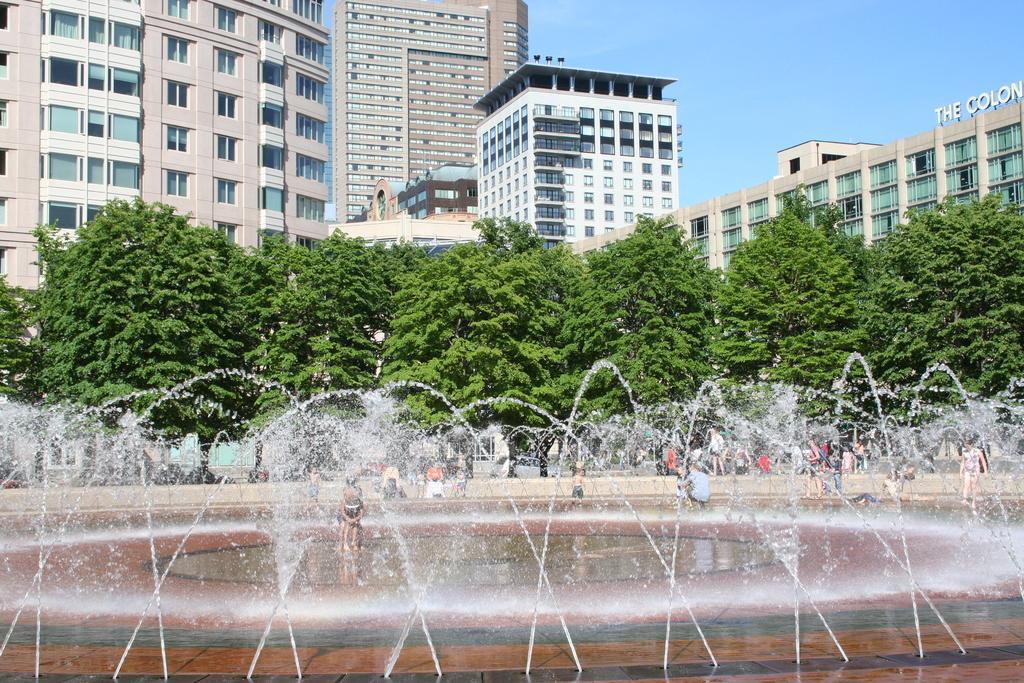Please provide a concise description of this image. In this picture we can see water, trees, buildings, name board and a group of people and some objects and in the background we can see the sky. 